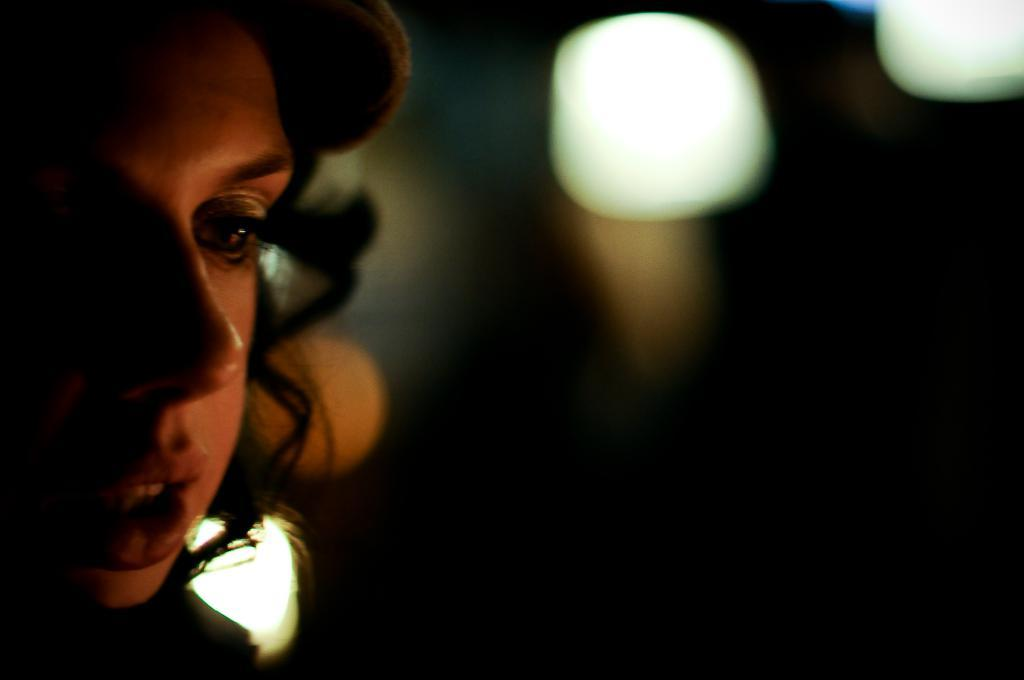What is the main subject of the image? There is a person in the image. Can you describe the background of the image? The background of the image is dark. What is the profit made by the waves during the journey in the image? There are no waves or journey mentioned in the image, and therefore no profit can be determined. 